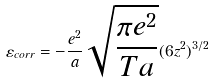<formula> <loc_0><loc_0><loc_500><loc_500>\varepsilon _ { c o r r } = - \frac { e ^ { 2 } } { a } \sqrt { \frac { \pi e ^ { 2 } } { T a } } ( 6 z ^ { 2 } ) ^ { 3 / 2 } \,</formula> 